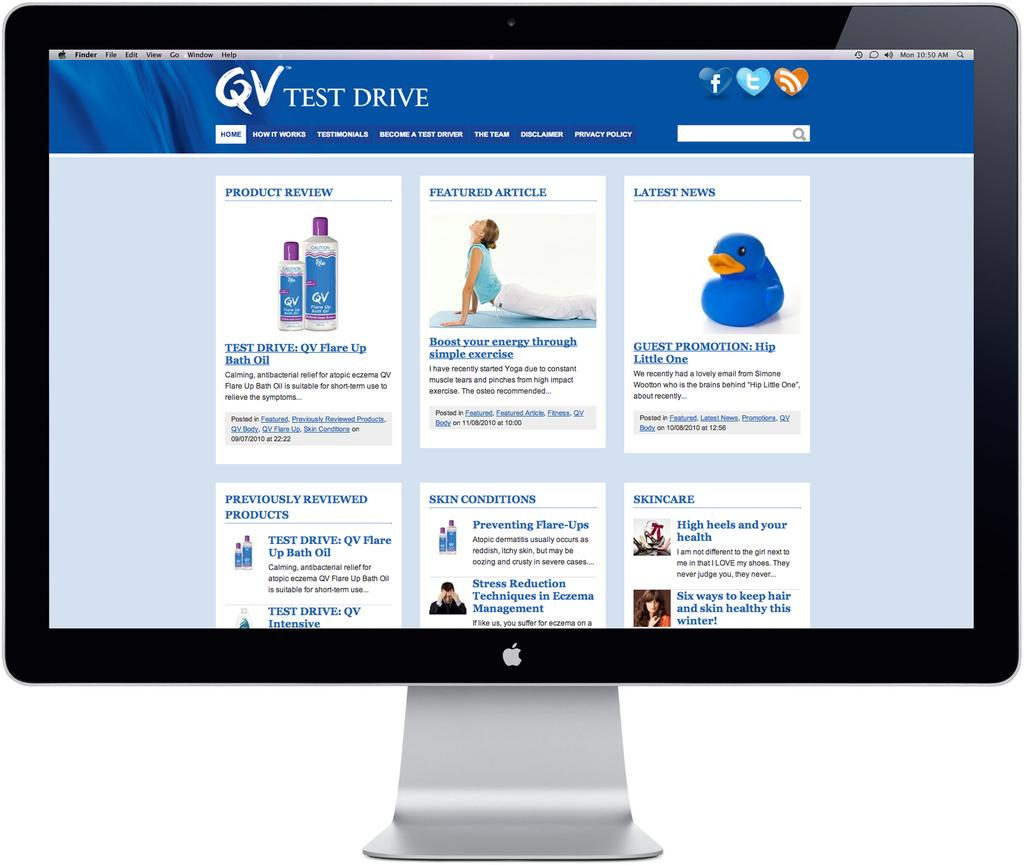<image>
Create a compact narrative representing the image presented. The blue and white website is by Test Drive 